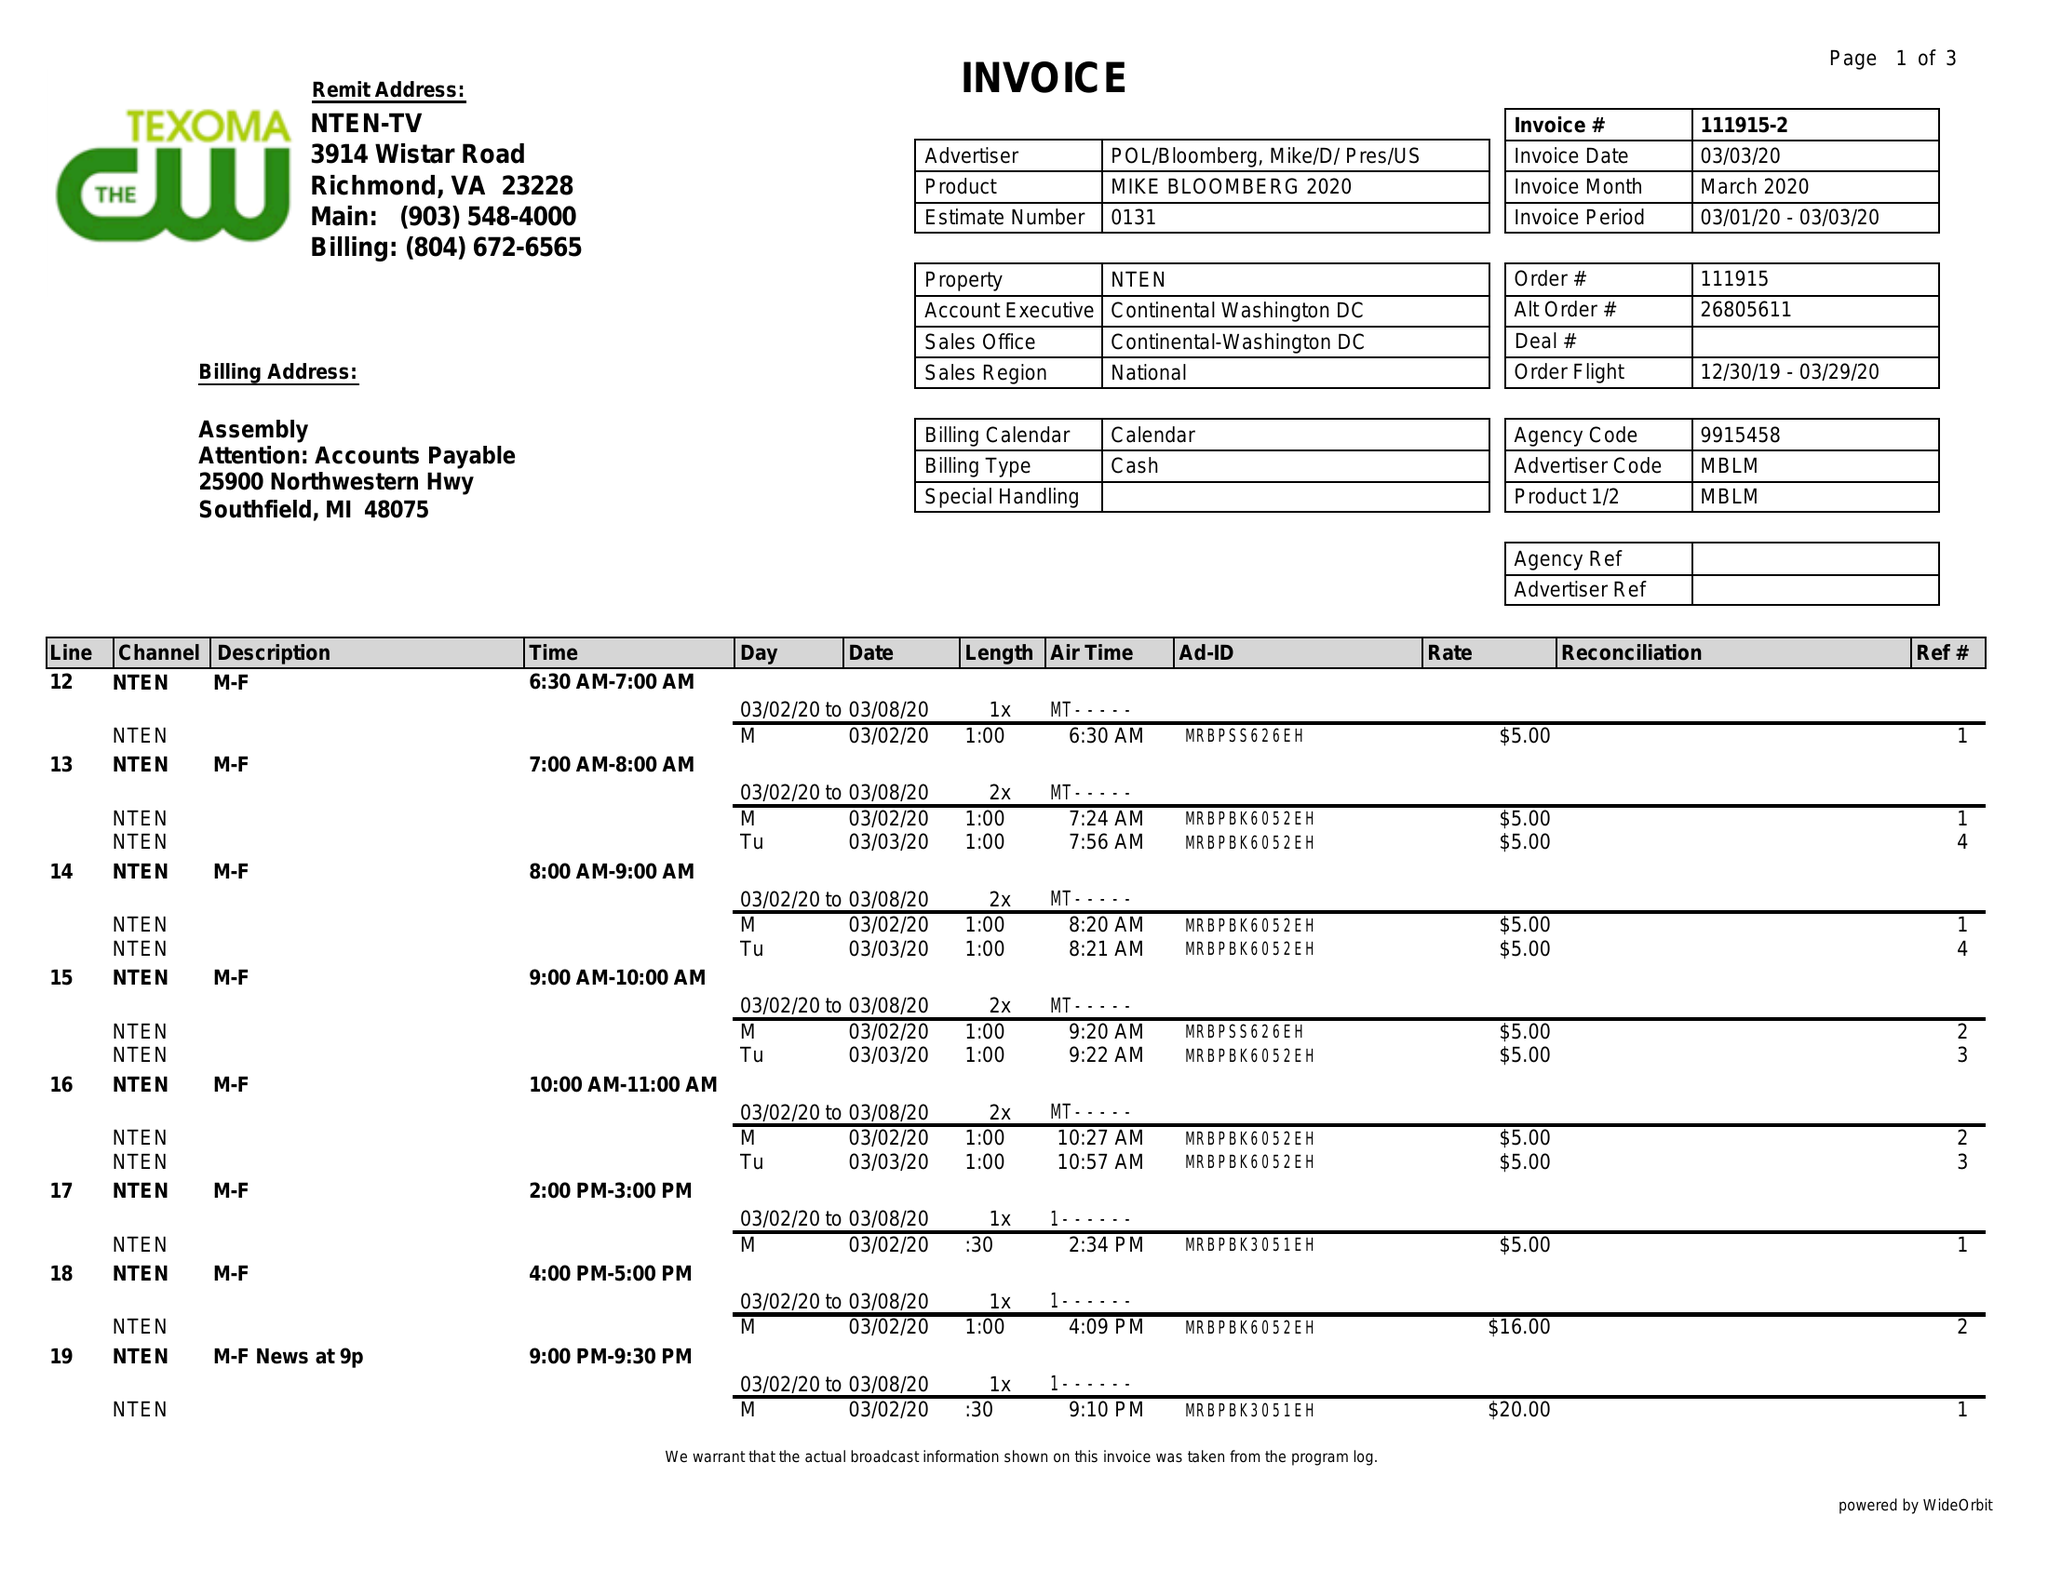What is the value for the gross_amount?
Answer the question using a single word or phrase. 212.00 